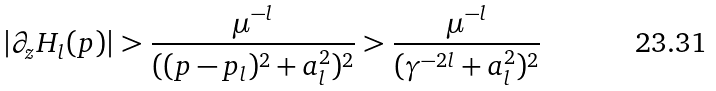Convert formula to latex. <formula><loc_0><loc_0><loc_500><loc_500>| \partial _ { z } H _ { l } ( p ) | > \frac { \mu ^ { - l } } { ( ( p - p _ { l } ) ^ { 2 } + a _ { l } ^ { 2 } ) ^ { 2 } } > \frac { \mu ^ { - l } } { ( \gamma ^ { - 2 l } + a _ { l } ^ { 2 } ) ^ { 2 } }</formula> 